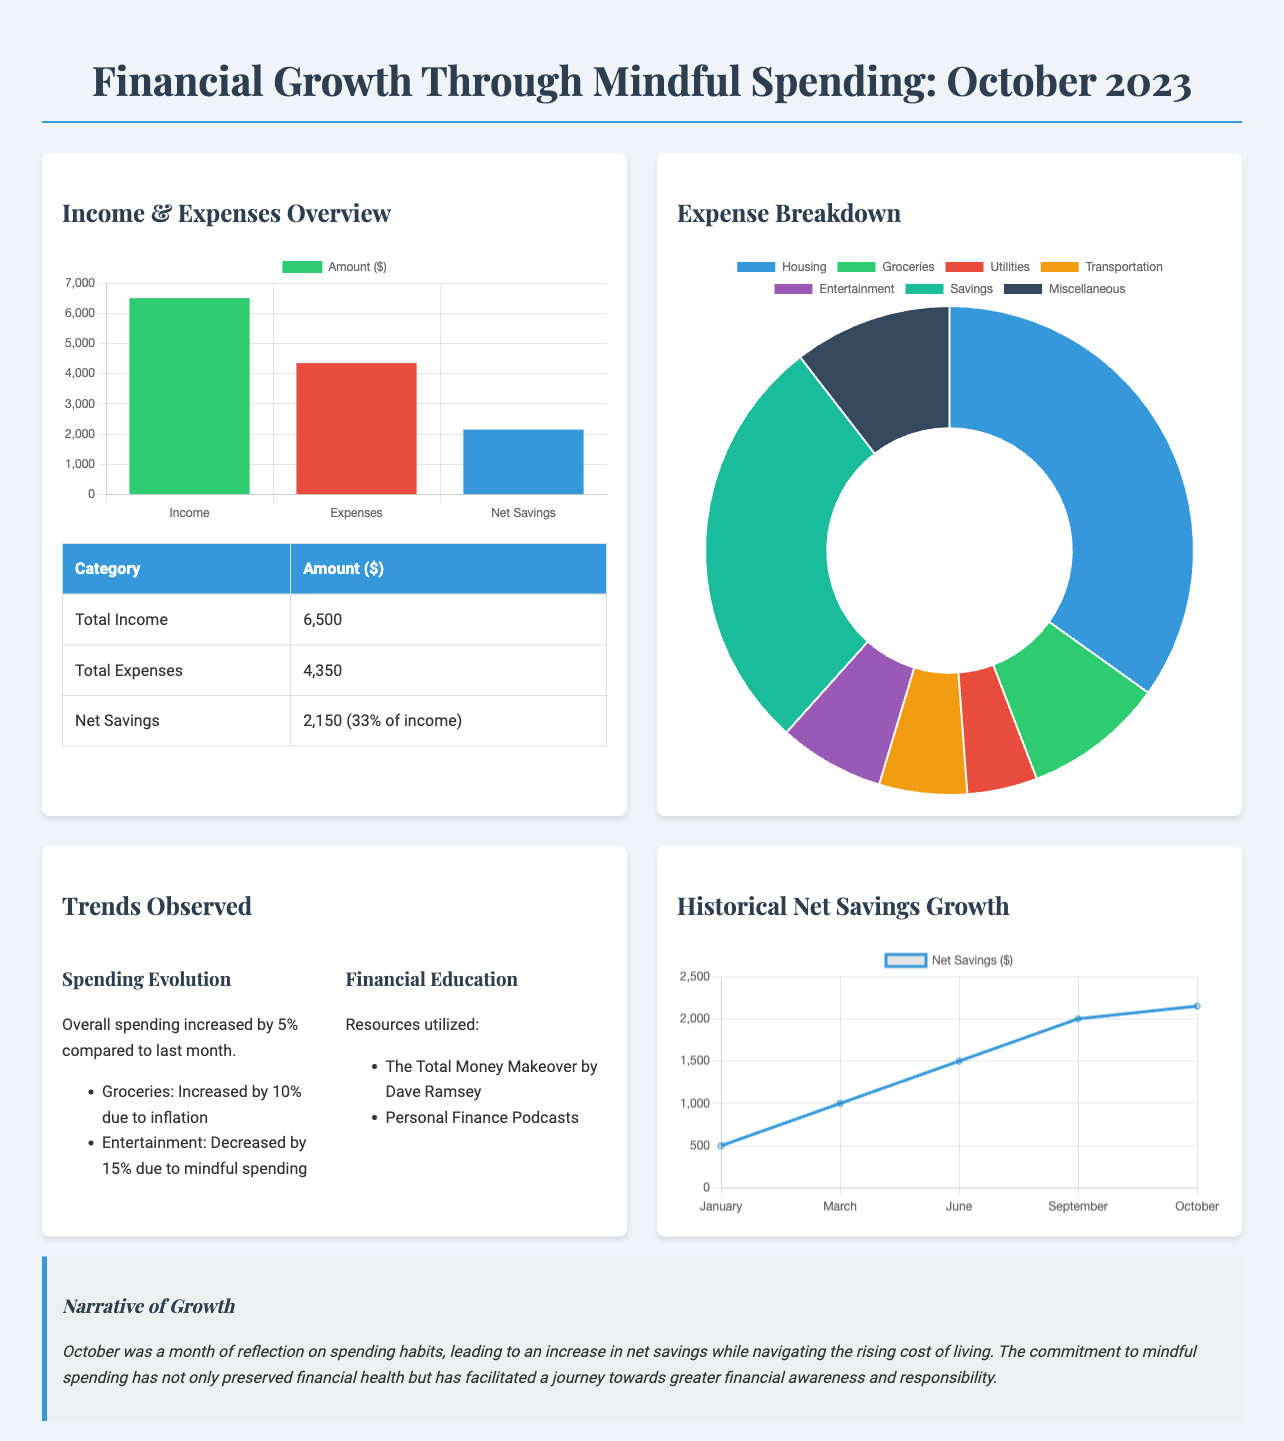what is the total income? The total income is listed in the document under "Total Income," which shows $6,500.
Answer: $6,500 what percentage of income is represented by net savings? Net savings as a percentage of total income is stated as 33% in the document.
Answer: 33% how much did expenses increase compared to last month? The document states that overall spending increased by 5% compared to last month.
Answer: 5% which category saw a decrease in spending? The document mentions that Entertainment spending decreased by 15%.
Answer: Entertainment what resources were utilized for financial education? The document lists two resources for financial education: The Total Money Makeover by Dave Ramsey and Personal Finance Podcasts.
Answer: The Total Money Makeover by Dave Ramsey, Personal Finance Podcasts how much is allocated for groceries in the expense breakdown? The expense breakdown indicates that $400 is allocated for groceries.
Answer: $400 what was the net savings for October? The document reveals that the net savings for October is $2,150.
Answer: $2,150 what theme does the narrative of growth highlight for October? The narrative reflects on mindful spending and its impact on financial health for the month.
Answer: Mindful spending what is the total amount spent on utilities? According to the expense breakdown, the total amount spent on Utilities is $200.
Answer: $200 